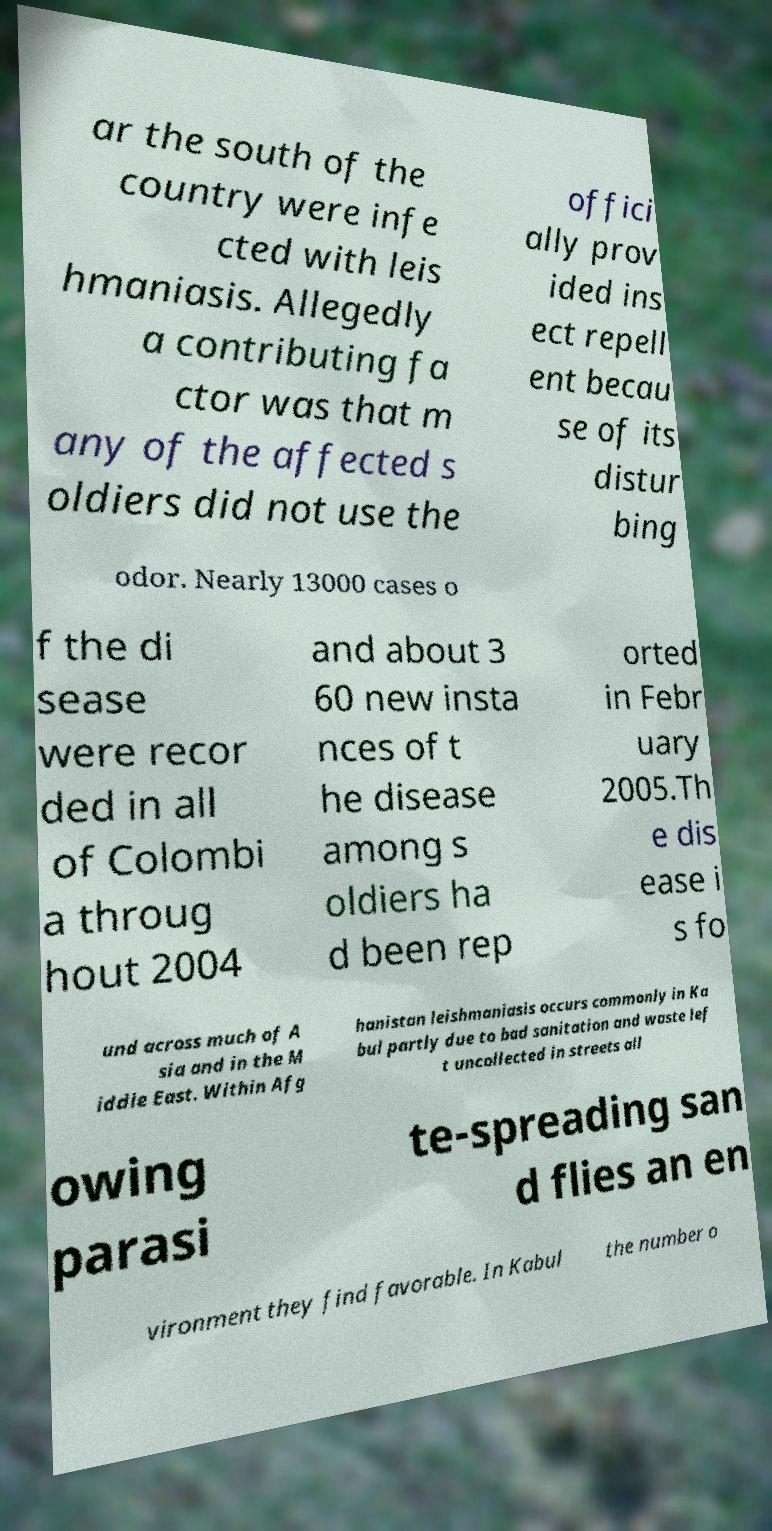For documentation purposes, I need the text within this image transcribed. Could you provide that? ar the south of the country were infe cted with leis hmaniasis. Allegedly a contributing fa ctor was that m any of the affected s oldiers did not use the offici ally prov ided ins ect repell ent becau se of its distur bing odor. Nearly 13000 cases o f the di sease were recor ded in all of Colombi a throug hout 2004 and about 3 60 new insta nces of t he disease among s oldiers ha d been rep orted in Febr uary 2005.Th e dis ease i s fo und across much of A sia and in the M iddle East. Within Afg hanistan leishmaniasis occurs commonly in Ka bul partly due to bad sanitation and waste lef t uncollected in streets all owing parasi te-spreading san d flies an en vironment they find favorable. In Kabul the number o 